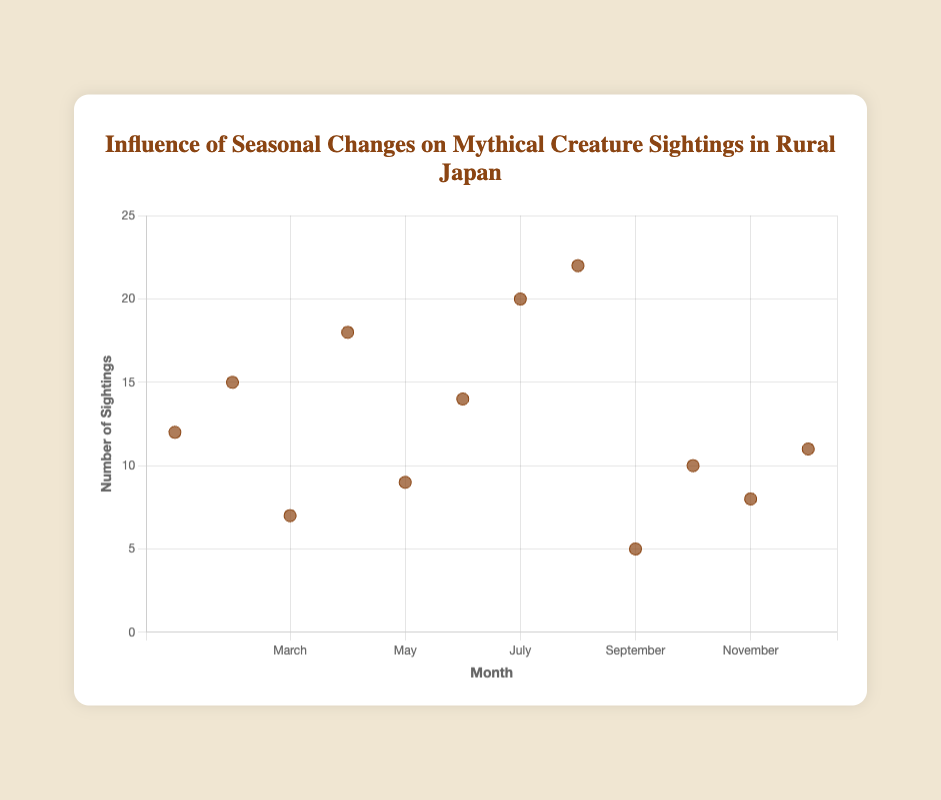What's the highest number of sightings for any creature in a single month? Look at the y-axis to find the highest value among all points. The highest y-value is 22 in August.
Answer: 22 In which month were the sightings for Yuki-onna recorded? Look at the data points and refer to the tooltip or legend for creature names. Yuki-onna sightings were recorded in January and February.
Answer: January and February How do the sightings of Kappa change from March to April? Identify the data points for Kappa in March and April and compare their y-values. Sightings increased from 7 in March to 18 in April.
Answer: Increase What is the average number of sightings for Tengu across the months they appear? Find the sightings for Tengu in May and June, sum them up (9 + 14) = 23, and divide by the number of months (23 / 2).
Answer: 11.5 Which creature had the highest number of sightings in July? Refer to the data points for July and their corresponding creatures. Kitsune had 20 sightings in July, which is the highest.
Answer: Kitsune Are the sightings of Tsukumogami higher in December than in November? Compare the y-values for Tsukumogami in December (11) and November (8). Sightings in December are higher.
Answer: Yes What is the difference in the number of sightings between Kodama in September and October? Subtract the sightings in September (5) from the sightings in October (10). The difference is 10 - 5 = 5.
Answer: 5 Which month has the least number of creature sightings? Find the data point with the lowest y-value. The least sightings (5) occur in September.
Answer: September How does the trend of Kitsune sightings change between July and August? Look at the y-values for Kitsune in July (20) and August (22). Sightings increase from July to August.
Answer: Increase 